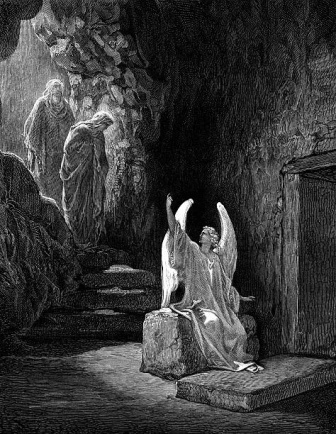Describe the sense of atmosphere that the artist has created in this cave illustration. The artist has crafted a deeply atmospheric and evocative scene within the cave. The interplay of light and shadow creates a stark contrast, emphasizing the cavernous space and the figures within it. The angel's luminous halo and robe catch the light, making it the focal point and infusing the scene with a divine and ethereal quality. The rough, textured stone walls and staircase contribute to the rugged and natural ambiance, while the enclosed space of the cave suggests seclusion and mystery. Overall, the atmosphere balances between sacred and somber, invoking a sense of awe and contemplation. If this cave could speak, what stories might it tell about the figures within it? If the cave could speak, it might tell tales of ancient rituals and divine encounters that have taken place within its walls. It could reveal the origin and purpose of the angel's visit—perhaps a mission of guidance, protection, or revelation. The cave might share stories of the two cloaked figures, suggesting they are pilgrims, seekers of wisdom, or guardians of a sacred secret. It could recount their journeys, struggles, and the moments of solace they found within its depths. The cave's narrative would be one of spiritual quests, hidden knowledge, and the intersection between the mortal and the divine.  Imagine a scenario: The angel is speaking to the figures. What might it be saying? In this imagined scenario, the angel could be delivering a message of profound significance to the figures. Perhaps it is offering words of comfort and guidance, unveiling a prophecy, or imparting divine wisdom. The angel might be instructing them on a sacred journey or revealing truths that could alter their destinies. The figures, in turn, may be listening in reverence, absorbing every word with a deep sense of purpose and understanding. This conversation could mark a pivotal moment in their lives, one that intertwines their fates with the celestial being's divine mission. 